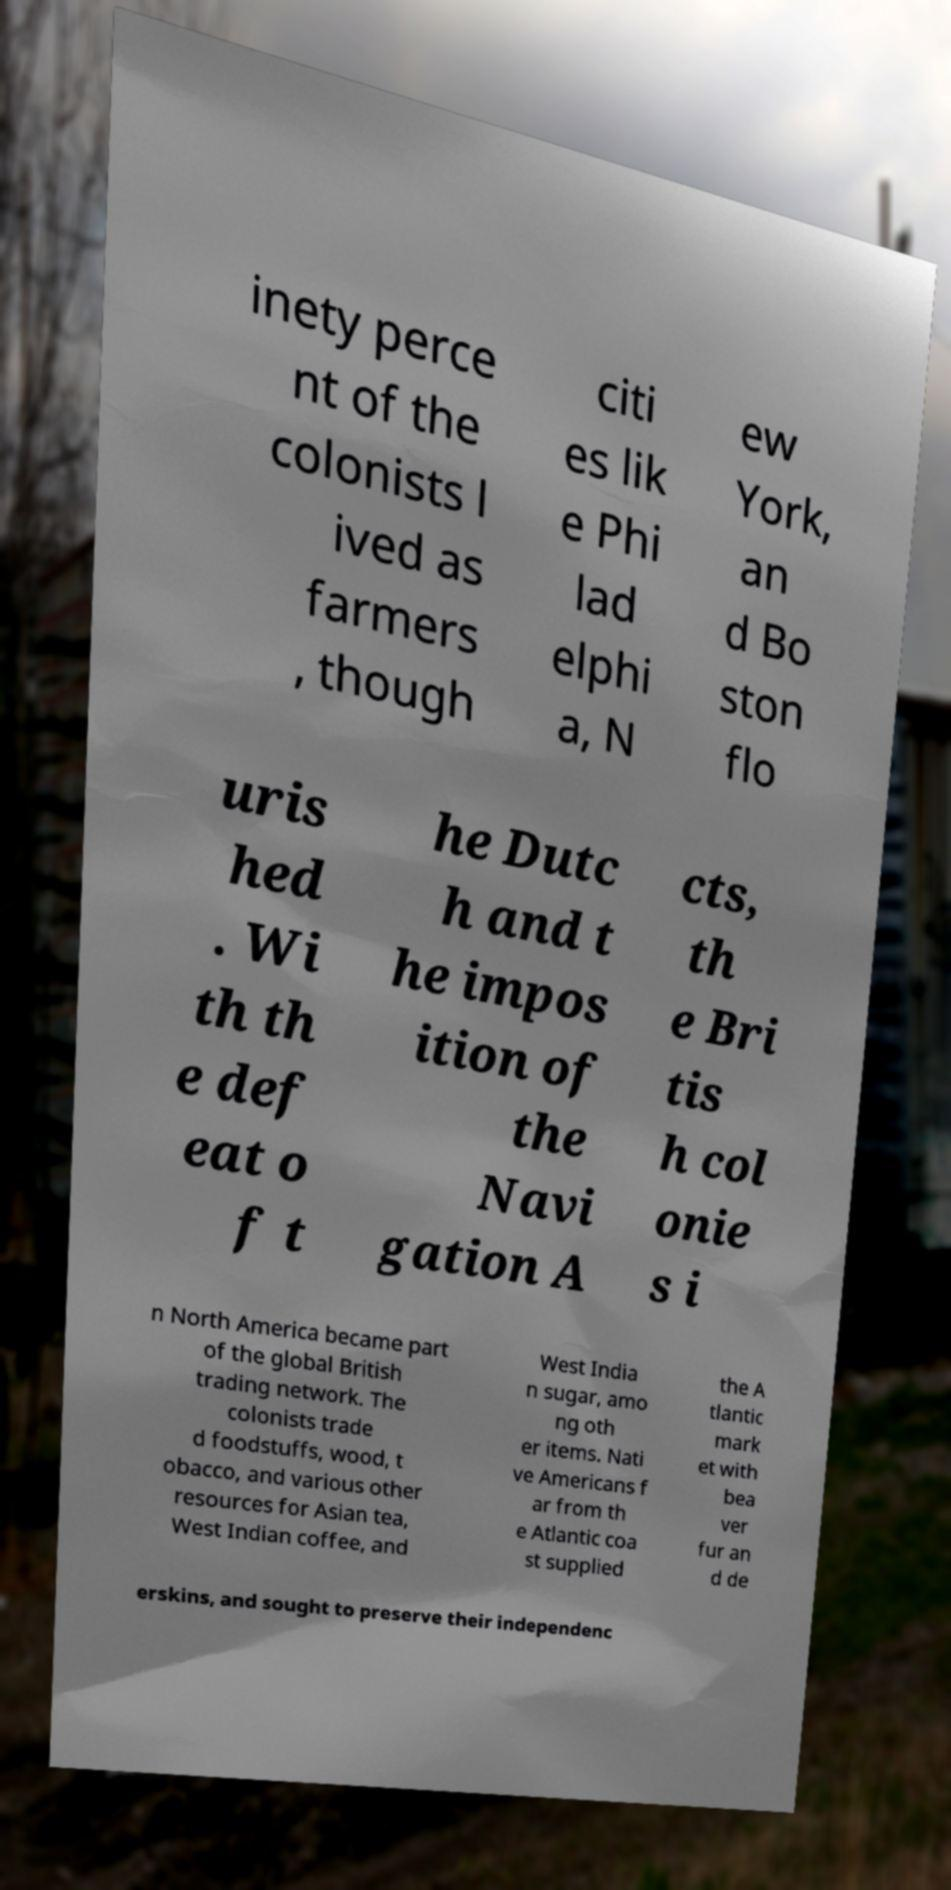Can you read and provide the text displayed in the image?This photo seems to have some interesting text. Can you extract and type it out for me? inety perce nt of the colonists l ived as farmers , though citi es lik e Phi lad elphi a, N ew York, an d Bo ston flo uris hed . Wi th th e def eat o f t he Dutc h and t he impos ition of the Navi gation A cts, th e Bri tis h col onie s i n North America became part of the global British trading network. The colonists trade d foodstuffs, wood, t obacco, and various other resources for Asian tea, West Indian coffee, and West India n sugar, amo ng oth er items. Nati ve Americans f ar from th e Atlantic coa st supplied the A tlantic mark et with bea ver fur an d de erskins, and sought to preserve their independenc 